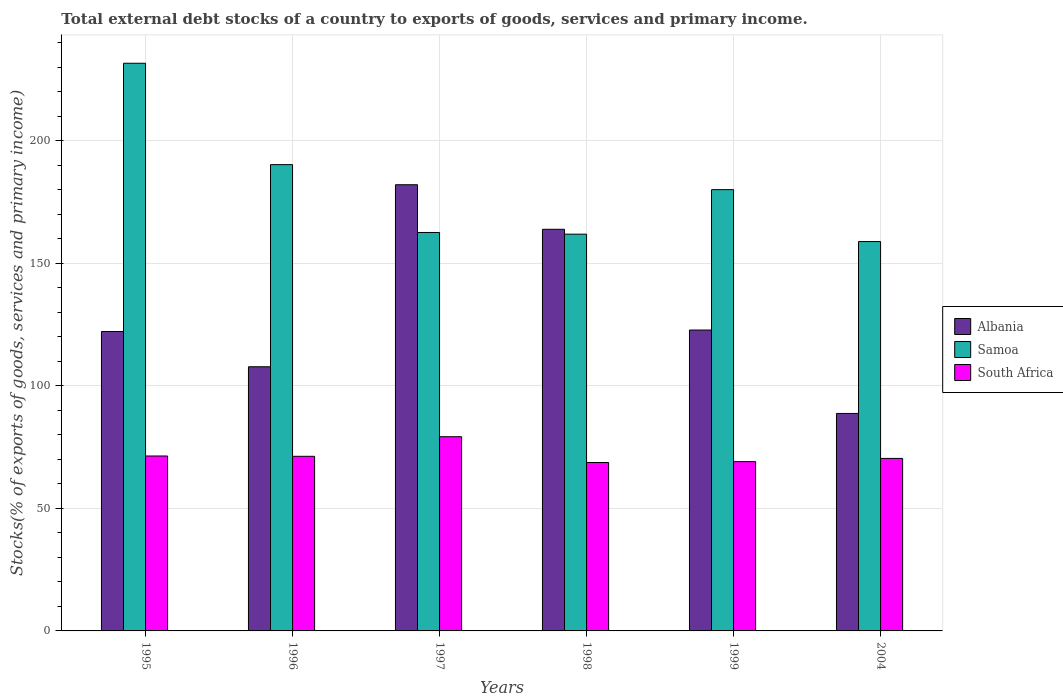How many different coloured bars are there?
Offer a terse response. 3. Are the number of bars per tick equal to the number of legend labels?
Offer a very short reply. Yes. Are the number of bars on each tick of the X-axis equal?
Your response must be concise. Yes. What is the label of the 1st group of bars from the left?
Provide a short and direct response. 1995. In how many cases, is the number of bars for a given year not equal to the number of legend labels?
Offer a terse response. 0. What is the total debt stocks in South Africa in 2004?
Keep it short and to the point. 70.36. Across all years, what is the maximum total debt stocks in Albania?
Keep it short and to the point. 182. Across all years, what is the minimum total debt stocks in Samoa?
Provide a succinct answer. 158.82. In which year was the total debt stocks in Albania maximum?
Offer a very short reply. 1997. What is the total total debt stocks in Samoa in the graph?
Provide a short and direct response. 1084.93. What is the difference between the total debt stocks in Albania in 1996 and that in 1998?
Offer a terse response. -56.08. What is the difference between the total debt stocks in South Africa in 1996 and the total debt stocks in Samoa in 1999?
Offer a terse response. -108.77. What is the average total debt stocks in Samoa per year?
Your answer should be very brief. 180.82. In the year 1999, what is the difference between the total debt stocks in Albania and total debt stocks in South Africa?
Make the answer very short. 53.68. In how many years, is the total debt stocks in South Africa greater than 140 %?
Your response must be concise. 0. What is the ratio of the total debt stocks in South Africa in 1998 to that in 2004?
Your answer should be compact. 0.98. Is the total debt stocks in Albania in 1998 less than that in 1999?
Offer a very short reply. No. Is the difference between the total debt stocks in Albania in 1996 and 1998 greater than the difference between the total debt stocks in South Africa in 1996 and 1998?
Keep it short and to the point. No. What is the difference between the highest and the second highest total debt stocks in South Africa?
Ensure brevity in your answer.  7.87. What is the difference between the highest and the lowest total debt stocks in Albania?
Provide a succinct answer. 93.29. What does the 3rd bar from the left in 1998 represents?
Your answer should be very brief. South Africa. What does the 1st bar from the right in 1998 represents?
Provide a short and direct response. South Africa. Is it the case that in every year, the sum of the total debt stocks in South Africa and total debt stocks in Albania is greater than the total debt stocks in Samoa?
Provide a short and direct response. No. How many bars are there?
Provide a succinct answer. 18. Are all the bars in the graph horizontal?
Keep it short and to the point. No. How many years are there in the graph?
Keep it short and to the point. 6. Does the graph contain grids?
Your answer should be very brief. Yes. Where does the legend appear in the graph?
Your answer should be very brief. Center right. How many legend labels are there?
Your answer should be compact. 3. What is the title of the graph?
Offer a very short reply. Total external debt stocks of a country to exports of goods, services and primary income. Does "Paraguay" appear as one of the legend labels in the graph?
Your answer should be compact. No. What is the label or title of the X-axis?
Give a very brief answer. Years. What is the label or title of the Y-axis?
Offer a very short reply. Stocks(% of exports of goods, services and primary income). What is the Stocks(% of exports of goods, services and primary income) in Albania in 1995?
Make the answer very short. 122.13. What is the Stocks(% of exports of goods, services and primary income) of Samoa in 1995?
Offer a very short reply. 231.55. What is the Stocks(% of exports of goods, services and primary income) of South Africa in 1995?
Give a very brief answer. 71.35. What is the Stocks(% of exports of goods, services and primary income) in Albania in 1996?
Provide a succinct answer. 107.75. What is the Stocks(% of exports of goods, services and primary income) in Samoa in 1996?
Your answer should be compact. 190.2. What is the Stocks(% of exports of goods, services and primary income) in South Africa in 1996?
Your answer should be very brief. 71.23. What is the Stocks(% of exports of goods, services and primary income) in Albania in 1997?
Give a very brief answer. 182. What is the Stocks(% of exports of goods, services and primary income) of Samoa in 1997?
Your response must be concise. 162.53. What is the Stocks(% of exports of goods, services and primary income) of South Africa in 1997?
Keep it short and to the point. 79.22. What is the Stocks(% of exports of goods, services and primary income) in Albania in 1998?
Offer a very short reply. 163.83. What is the Stocks(% of exports of goods, services and primary income) in Samoa in 1998?
Offer a terse response. 161.84. What is the Stocks(% of exports of goods, services and primary income) in South Africa in 1998?
Provide a succinct answer. 68.7. What is the Stocks(% of exports of goods, services and primary income) of Albania in 1999?
Give a very brief answer. 122.73. What is the Stocks(% of exports of goods, services and primary income) of Samoa in 1999?
Offer a very short reply. 180. What is the Stocks(% of exports of goods, services and primary income) in South Africa in 1999?
Make the answer very short. 69.05. What is the Stocks(% of exports of goods, services and primary income) in Albania in 2004?
Provide a short and direct response. 88.71. What is the Stocks(% of exports of goods, services and primary income) in Samoa in 2004?
Provide a succinct answer. 158.82. What is the Stocks(% of exports of goods, services and primary income) in South Africa in 2004?
Your answer should be very brief. 70.36. Across all years, what is the maximum Stocks(% of exports of goods, services and primary income) of Albania?
Provide a short and direct response. 182. Across all years, what is the maximum Stocks(% of exports of goods, services and primary income) in Samoa?
Ensure brevity in your answer.  231.55. Across all years, what is the maximum Stocks(% of exports of goods, services and primary income) of South Africa?
Your answer should be compact. 79.22. Across all years, what is the minimum Stocks(% of exports of goods, services and primary income) of Albania?
Offer a very short reply. 88.71. Across all years, what is the minimum Stocks(% of exports of goods, services and primary income) of Samoa?
Your response must be concise. 158.82. Across all years, what is the minimum Stocks(% of exports of goods, services and primary income) of South Africa?
Keep it short and to the point. 68.7. What is the total Stocks(% of exports of goods, services and primary income) in Albania in the graph?
Ensure brevity in your answer.  787.15. What is the total Stocks(% of exports of goods, services and primary income) in Samoa in the graph?
Your answer should be compact. 1084.93. What is the total Stocks(% of exports of goods, services and primary income) of South Africa in the graph?
Your response must be concise. 429.92. What is the difference between the Stocks(% of exports of goods, services and primary income) in Albania in 1995 and that in 1996?
Your answer should be compact. 14.38. What is the difference between the Stocks(% of exports of goods, services and primary income) of Samoa in 1995 and that in 1996?
Your answer should be very brief. 41.35. What is the difference between the Stocks(% of exports of goods, services and primary income) of South Africa in 1995 and that in 1996?
Offer a terse response. 0.13. What is the difference between the Stocks(% of exports of goods, services and primary income) of Albania in 1995 and that in 1997?
Make the answer very short. -59.87. What is the difference between the Stocks(% of exports of goods, services and primary income) of Samoa in 1995 and that in 1997?
Your response must be concise. 69.03. What is the difference between the Stocks(% of exports of goods, services and primary income) of South Africa in 1995 and that in 1997?
Provide a succinct answer. -7.87. What is the difference between the Stocks(% of exports of goods, services and primary income) in Albania in 1995 and that in 1998?
Your answer should be compact. -41.7. What is the difference between the Stocks(% of exports of goods, services and primary income) in Samoa in 1995 and that in 1998?
Your answer should be compact. 69.71. What is the difference between the Stocks(% of exports of goods, services and primary income) of South Africa in 1995 and that in 1998?
Provide a succinct answer. 2.66. What is the difference between the Stocks(% of exports of goods, services and primary income) in Albania in 1995 and that in 1999?
Your answer should be very brief. -0.6. What is the difference between the Stocks(% of exports of goods, services and primary income) of Samoa in 1995 and that in 1999?
Your answer should be compact. 51.55. What is the difference between the Stocks(% of exports of goods, services and primary income) in South Africa in 1995 and that in 1999?
Make the answer very short. 2.3. What is the difference between the Stocks(% of exports of goods, services and primary income) in Albania in 1995 and that in 2004?
Your response must be concise. 33.42. What is the difference between the Stocks(% of exports of goods, services and primary income) of Samoa in 1995 and that in 2004?
Keep it short and to the point. 72.73. What is the difference between the Stocks(% of exports of goods, services and primary income) in Albania in 1996 and that in 1997?
Offer a very short reply. -74.25. What is the difference between the Stocks(% of exports of goods, services and primary income) in Samoa in 1996 and that in 1997?
Provide a short and direct response. 27.67. What is the difference between the Stocks(% of exports of goods, services and primary income) in South Africa in 1996 and that in 1997?
Provide a short and direct response. -7.99. What is the difference between the Stocks(% of exports of goods, services and primary income) of Albania in 1996 and that in 1998?
Keep it short and to the point. -56.08. What is the difference between the Stocks(% of exports of goods, services and primary income) of Samoa in 1996 and that in 1998?
Offer a terse response. 28.36. What is the difference between the Stocks(% of exports of goods, services and primary income) in South Africa in 1996 and that in 1998?
Ensure brevity in your answer.  2.53. What is the difference between the Stocks(% of exports of goods, services and primary income) in Albania in 1996 and that in 1999?
Make the answer very short. -14.98. What is the difference between the Stocks(% of exports of goods, services and primary income) of Samoa in 1996 and that in 1999?
Give a very brief answer. 10.2. What is the difference between the Stocks(% of exports of goods, services and primary income) in South Africa in 1996 and that in 1999?
Provide a short and direct response. 2.18. What is the difference between the Stocks(% of exports of goods, services and primary income) of Albania in 1996 and that in 2004?
Your answer should be compact. 19.04. What is the difference between the Stocks(% of exports of goods, services and primary income) in Samoa in 1996 and that in 2004?
Give a very brief answer. 31.38. What is the difference between the Stocks(% of exports of goods, services and primary income) in South Africa in 1996 and that in 2004?
Keep it short and to the point. 0.86. What is the difference between the Stocks(% of exports of goods, services and primary income) of Albania in 1997 and that in 1998?
Give a very brief answer. 18.17. What is the difference between the Stocks(% of exports of goods, services and primary income) of Samoa in 1997 and that in 1998?
Provide a short and direct response. 0.68. What is the difference between the Stocks(% of exports of goods, services and primary income) in South Africa in 1997 and that in 1998?
Your answer should be very brief. 10.52. What is the difference between the Stocks(% of exports of goods, services and primary income) of Albania in 1997 and that in 1999?
Offer a terse response. 59.27. What is the difference between the Stocks(% of exports of goods, services and primary income) of Samoa in 1997 and that in 1999?
Give a very brief answer. -17.47. What is the difference between the Stocks(% of exports of goods, services and primary income) of South Africa in 1997 and that in 1999?
Provide a short and direct response. 10.17. What is the difference between the Stocks(% of exports of goods, services and primary income) of Albania in 1997 and that in 2004?
Ensure brevity in your answer.  93.29. What is the difference between the Stocks(% of exports of goods, services and primary income) of Samoa in 1997 and that in 2004?
Provide a succinct answer. 3.71. What is the difference between the Stocks(% of exports of goods, services and primary income) of South Africa in 1997 and that in 2004?
Give a very brief answer. 8.86. What is the difference between the Stocks(% of exports of goods, services and primary income) of Albania in 1998 and that in 1999?
Your response must be concise. 41.09. What is the difference between the Stocks(% of exports of goods, services and primary income) of Samoa in 1998 and that in 1999?
Provide a short and direct response. -18.16. What is the difference between the Stocks(% of exports of goods, services and primary income) of South Africa in 1998 and that in 1999?
Give a very brief answer. -0.35. What is the difference between the Stocks(% of exports of goods, services and primary income) in Albania in 1998 and that in 2004?
Give a very brief answer. 75.12. What is the difference between the Stocks(% of exports of goods, services and primary income) of Samoa in 1998 and that in 2004?
Your answer should be compact. 3.02. What is the difference between the Stocks(% of exports of goods, services and primary income) in South Africa in 1998 and that in 2004?
Your answer should be very brief. -1.67. What is the difference between the Stocks(% of exports of goods, services and primary income) of Albania in 1999 and that in 2004?
Offer a very short reply. 34.02. What is the difference between the Stocks(% of exports of goods, services and primary income) in Samoa in 1999 and that in 2004?
Offer a very short reply. 21.18. What is the difference between the Stocks(% of exports of goods, services and primary income) of South Africa in 1999 and that in 2004?
Your response must be concise. -1.31. What is the difference between the Stocks(% of exports of goods, services and primary income) of Albania in 1995 and the Stocks(% of exports of goods, services and primary income) of Samoa in 1996?
Provide a short and direct response. -68.07. What is the difference between the Stocks(% of exports of goods, services and primary income) in Albania in 1995 and the Stocks(% of exports of goods, services and primary income) in South Africa in 1996?
Your response must be concise. 50.9. What is the difference between the Stocks(% of exports of goods, services and primary income) in Samoa in 1995 and the Stocks(% of exports of goods, services and primary income) in South Africa in 1996?
Keep it short and to the point. 160.32. What is the difference between the Stocks(% of exports of goods, services and primary income) in Albania in 1995 and the Stocks(% of exports of goods, services and primary income) in Samoa in 1997?
Provide a short and direct response. -40.39. What is the difference between the Stocks(% of exports of goods, services and primary income) of Albania in 1995 and the Stocks(% of exports of goods, services and primary income) of South Africa in 1997?
Ensure brevity in your answer.  42.91. What is the difference between the Stocks(% of exports of goods, services and primary income) in Samoa in 1995 and the Stocks(% of exports of goods, services and primary income) in South Africa in 1997?
Provide a succinct answer. 152.33. What is the difference between the Stocks(% of exports of goods, services and primary income) in Albania in 1995 and the Stocks(% of exports of goods, services and primary income) in Samoa in 1998?
Provide a short and direct response. -39.71. What is the difference between the Stocks(% of exports of goods, services and primary income) of Albania in 1995 and the Stocks(% of exports of goods, services and primary income) of South Africa in 1998?
Offer a terse response. 53.43. What is the difference between the Stocks(% of exports of goods, services and primary income) in Samoa in 1995 and the Stocks(% of exports of goods, services and primary income) in South Africa in 1998?
Give a very brief answer. 162.85. What is the difference between the Stocks(% of exports of goods, services and primary income) in Albania in 1995 and the Stocks(% of exports of goods, services and primary income) in Samoa in 1999?
Make the answer very short. -57.87. What is the difference between the Stocks(% of exports of goods, services and primary income) of Albania in 1995 and the Stocks(% of exports of goods, services and primary income) of South Africa in 1999?
Give a very brief answer. 53.08. What is the difference between the Stocks(% of exports of goods, services and primary income) in Samoa in 1995 and the Stocks(% of exports of goods, services and primary income) in South Africa in 1999?
Your response must be concise. 162.5. What is the difference between the Stocks(% of exports of goods, services and primary income) of Albania in 1995 and the Stocks(% of exports of goods, services and primary income) of Samoa in 2004?
Your answer should be compact. -36.69. What is the difference between the Stocks(% of exports of goods, services and primary income) of Albania in 1995 and the Stocks(% of exports of goods, services and primary income) of South Africa in 2004?
Keep it short and to the point. 51.77. What is the difference between the Stocks(% of exports of goods, services and primary income) in Samoa in 1995 and the Stocks(% of exports of goods, services and primary income) in South Africa in 2004?
Make the answer very short. 161.19. What is the difference between the Stocks(% of exports of goods, services and primary income) in Albania in 1996 and the Stocks(% of exports of goods, services and primary income) in Samoa in 1997?
Provide a succinct answer. -54.77. What is the difference between the Stocks(% of exports of goods, services and primary income) of Albania in 1996 and the Stocks(% of exports of goods, services and primary income) of South Africa in 1997?
Ensure brevity in your answer.  28.53. What is the difference between the Stocks(% of exports of goods, services and primary income) of Samoa in 1996 and the Stocks(% of exports of goods, services and primary income) of South Africa in 1997?
Offer a very short reply. 110.98. What is the difference between the Stocks(% of exports of goods, services and primary income) of Albania in 1996 and the Stocks(% of exports of goods, services and primary income) of Samoa in 1998?
Your answer should be very brief. -54.09. What is the difference between the Stocks(% of exports of goods, services and primary income) in Albania in 1996 and the Stocks(% of exports of goods, services and primary income) in South Africa in 1998?
Give a very brief answer. 39.05. What is the difference between the Stocks(% of exports of goods, services and primary income) of Samoa in 1996 and the Stocks(% of exports of goods, services and primary income) of South Africa in 1998?
Make the answer very short. 121.5. What is the difference between the Stocks(% of exports of goods, services and primary income) of Albania in 1996 and the Stocks(% of exports of goods, services and primary income) of Samoa in 1999?
Provide a succinct answer. -72.25. What is the difference between the Stocks(% of exports of goods, services and primary income) in Albania in 1996 and the Stocks(% of exports of goods, services and primary income) in South Africa in 1999?
Ensure brevity in your answer.  38.7. What is the difference between the Stocks(% of exports of goods, services and primary income) in Samoa in 1996 and the Stocks(% of exports of goods, services and primary income) in South Africa in 1999?
Make the answer very short. 121.15. What is the difference between the Stocks(% of exports of goods, services and primary income) of Albania in 1996 and the Stocks(% of exports of goods, services and primary income) of Samoa in 2004?
Make the answer very short. -51.07. What is the difference between the Stocks(% of exports of goods, services and primary income) in Albania in 1996 and the Stocks(% of exports of goods, services and primary income) in South Africa in 2004?
Keep it short and to the point. 37.39. What is the difference between the Stocks(% of exports of goods, services and primary income) in Samoa in 1996 and the Stocks(% of exports of goods, services and primary income) in South Africa in 2004?
Your answer should be compact. 119.83. What is the difference between the Stocks(% of exports of goods, services and primary income) in Albania in 1997 and the Stocks(% of exports of goods, services and primary income) in Samoa in 1998?
Ensure brevity in your answer.  20.16. What is the difference between the Stocks(% of exports of goods, services and primary income) in Albania in 1997 and the Stocks(% of exports of goods, services and primary income) in South Africa in 1998?
Make the answer very short. 113.3. What is the difference between the Stocks(% of exports of goods, services and primary income) in Samoa in 1997 and the Stocks(% of exports of goods, services and primary income) in South Africa in 1998?
Keep it short and to the point. 93.83. What is the difference between the Stocks(% of exports of goods, services and primary income) in Albania in 1997 and the Stocks(% of exports of goods, services and primary income) in Samoa in 1999?
Give a very brief answer. 2. What is the difference between the Stocks(% of exports of goods, services and primary income) of Albania in 1997 and the Stocks(% of exports of goods, services and primary income) of South Africa in 1999?
Your answer should be compact. 112.95. What is the difference between the Stocks(% of exports of goods, services and primary income) of Samoa in 1997 and the Stocks(% of exports of goods, services and primary income) of South Africa in 1999?
Ensure brevity in your answer.  93.48. What is the difference between the Stocks(% of exports of goods, services and primary income) in Albania in 1997 and the Stocks(% of exports of goods, services and primary income) in Samoa in 2004?
Your answer should be very brief. 23.18. What is the difference between the Stocks(% of exports of goods, services and primary income) in Albania in 1997 and the Stocks(% of exports of goods, services and primary income) in South Africa in 2004?
Your answer should be compact. 111.63. What is the difference between the Stocks(% of exports of goods, services and primary income) of Samoa in 1997 and the Stocks(% of exports of goods, services and primary income) of South Africa in 2004?
Give a very brief answer. 92.16. What is the difference between the Stocks(% of exports of goods, services and primary income) in Albania in 1998 and the Stocks(% of exports of goods, services and primary income) in Samoa in 1999?
Ensure brevity in your answer.  -16.17. What is the difference between the Stocks(% of exports of goods, services and primary income) of Albania in 1998 and the Stocks(% of exports of goods, services and primary income) of South Africa in 1999?
Ensure brevity in your answer.  94.78. What is the difference between the Stocks(% of exports of goods, services and primary income) in Samoa in 1998 and the Stocks(% of exports of goods, services and primary income) in South Africa in 1999?
Your answer should be compact. 92.79. What is the difference between the Stocks(% of exports of goods, services and primary income) in Albania in 1998 and the Stocks(% of exports of goods, services and primary income) in Samoa in 2004?
Keep it short and to the point. 5.01. What is the difference between the Stocks(% of exports of goods, services and primary income) in Albania in 1998 and the Stocks(% of exports of goods, services and primary income) in South Africa in 2004?
Keep it short and to the point. 93.46. What is the difference between the Stocks(% of exports of goods, services and primary income) in Samoa in 1998 and the Stocks(% of exports of goods, services and primary income) in South Africa in 2004?
Provide a succinct answer. 91.48. What is the difference between the Stocks(% of exports of goods, services and primary income) in Albania in 1999 and the Stocks(% of exports of goods, services and primary income) in Samoa in 2004?
Ensure brevity in your answer.  -36.09. What is the difference between the Stocks(% of exports of goods, services and primary income) of Albania in 1999 and the Stocks(% of exports of goods, services and primary income) of South Africa in 2004?
Keep it short and to the point. 52.37. What is the difference between the Stocks(% of exports of goods, services and primary income) in Samoa in 1999 and the Stocks(% of exports of goods, services and primary income) in South Africa in 2004?
Your answer should be compact. 109.63. What is the average Stocks(% of exports of goods, services and primary income) of Albania per year?
Your answer should be very brief. 131.19. What is the average Stocks(% of exports of goods, services and primary income) in Samoa per year?
Your answer should be very brief. 180.82. What is the average Stocks(% of exports of goods, services and primary income) of South Africa per year?
Provide a short and direct response. 71.65. In the year 1995, what is the difference between the Stocks(% of exports of goods, services and primary income) of Albania and Stocks(% of exports of goods, services and primary income) of Samoa?
Ensure brevity in your answer.  -109.42. In the year 1995, what is the difference between the Stocks(% of exports of goods, services and primary income) of Albania and Stocks(% of exports of goods, services and primary income) of South Africa?
Make the answer very short. 50.78. In the year 1995, what is the difference between the Stocks(% of exports of goods, services and primary income) of Samoa and Stocks(% of exports of goods, services and primary income) of South Africa?
Your response must be concise. 160.2. In the year 1996, what is the difference between the Stocks(% of exports of goods, services and primary income) in Albania and Stocks(% of exports of goods, services and primary income) in Samoa?
Give a very brief answer. -82.45. In the year 1996, what is the difference between the Stocks(% of exports of goods, services and primary income) in Albania and Stocks(% of exports of goods, services and primary income) in South Africa?
Give a very brief answer. 36.52. In the year 1996, what is the difference between the Stocks(% of exports of goods, services and primary income) in Samoa and Stocks(% of exports of goods, services and primary income) in South Africa?
Keep it short and to the point. 118.97. In the year 1997, what is the difference between the Stocks(% of exports of goods, services and primary income) in Albania and Stocks(% of exports of goods, services and primary income) in Samoa?
Your answer should be compact. 19.47. In the year 1997, what is the difference between the Stocks(% of exports of goods, services and primary income) of Albania and Stocks(% of exports of goods, services and primary income) of South Africa?
Offer a terse response. 102.78. In the year 1997, what is the difference between the Stocks(% of exports of goods, services and primary income) of Samoa and Stocks(% of exports of goods, services and primary income) of South Africa?
Provide a short and direct response. 83.3. In the year 1998, what is the difference between the Stocks(% of exports of goods, services and primary income) in Albania and Stocks(% of exports of goods, services and primary income) in Samoa?
Offer a terse response. 1.99. In the year 1998, what is the difference between the Stocks(% of exports of goods, services and primary income) of Albania and Stocks(% of exports of goods, services and primary income) of South Africa?
Provide a succinct answer. 95.13. In the year 1998, what is the difference between the Stocks(% of exports of goods, services and primary income) in Samoa and Stocks(% of exports of goods, services and primary income) in South Africa?
Offer a terse response. 93.14. In the year 1999, what is the difference between the Stocks(% of exports of goods, services and primary income) of Albania and Stocks(% of exports of goods, services and primary income) of Samoa?
Your answer should be very brief. -57.27. In the year 1999, what is the difference between the Stocks(% of exports of goods, services and primary income) of Albania and Stocks(% of exports of goods, services and primary income) of South Africa?
Ensure brevity in your answer.  53.68. In the year 1999, what is the difference between the Stocks(% of exports of goods, services and primary income) of Samoa and Stocks(% of exports of goods, services and primary income) of South Africa?
Your answer should be compact. 110.95. In the year 2004, what is the difference between the Stocks(% of exports of goods, services and primary income) in Albania and Stocks(% of exports of goods, services and primary income) in Samoa?
Provide a succinct answer. -70.11. In the year 2004, what is the difference between the Stocks(% of exports of goods, services and primary income) of Albania and Stocks(% of exports of goods, services and primary income) of South Africa?
Give a very brief answer. 18.35. In the year 2004, what is the difference between the Stocks(% of exports of goods, services and primary income) of Samoa and Stocks(% of exports of goods, services and primary income) of South Africa?
Your response must be concise. 88.46. What is the ratio of the Stocks(% of exports of goods, services and primary income) of Albania in 1995 to that in 1996?
Your answer should be compact. 1.13. What is the ratio of the Stocks(% of exports of goods, services and primary income) of Samoa in 1995 to that in 1996?
Your response must be concise. 1.22. What is the ratio of the Stocks(% of exports of goods, services and primary income) of Albania in 1995 to that in 1997?
Make the answer very short. 0.67. What is the ratio of the Stocks(% of exports of goods, services and primary income) of Samoa in 1995 to that in 1997?
Keep it short and to the point. 1.42. What is the ratio of the Stocks(% of exports of goods, services and primary income) in South Africa in 1995 to that in 1997?
Provide a short and direct response. 0.9. What is the ratio of the Stocks(% of exports of goods, services and primary income) of Albania in 1995 to that in 1998?
Ensure brevity in your answer.  0.75. What is the ratio of the Stocks(% of exports of goods, services and primary income) in Samoa in 1995 to that in 1998?
Keep it short and to the point. 1.43. What is the ratio of the Stocks(% of exports of goods, services and primary income) of South Africa in 1995 to that in 1998?
Offer a terse response. 1.04. What is the ratio of the Stocks(% of exports of goods, services and primary income) of Samoa in 1995 to that in 1999?
Make the answer very short. 1.29. What is the ratio of the Stocks(% of exports of goods, services and primary income) of South Africa in 1995 to that in 1999?
Offer a very short reply. 1.03. What is the ratio of the Stocks(% of exports of goods, services and primary income) of Albania in 1995 to that in 2004?
Offer a terse response. 1.38. What is the ratio of the Stocks(% of exports of goods, services and primary income) in Samoa in 1995 to that in 2004?
Keep it short and to the point. 1.46. What is the ratio of the Stocks(% of exports of goods, services and primary income) of South Africa in 1995 to that in 2004?
Ensure brevity in your answer.  1.01. What is the ratio of the Stocks(% of exports of goods, services and primary income) of Albania in 1996 to that in 1997?
Make the answer very short. 0.59. What is the ratio of the Stocks(% of exports of goods, services and primary income) in Samoa in 1996 to that in 1997?
Offer a very short reply. 1.17. What is the ratio of the Stocks(% of exports of goods, services and primary income) of South Africa in 1996 to that in 1997?
Keep it short and to the point. 0.9. What is the ratio of the Stocks(% of exports of goods, services and primary income) of Albania in 1996 to that in 1998?
Your answer should be very brief. 0.66. What is the ratio of the Stocks(% of exports of goods, services and primary income) of Samoa in 1996 to that in 1998?
Your answer should be compact. 1.18. What is the ratio of the Stocks(% of exports of goods, services and primary income) of South Africa in 1996 to that in 1998?
Keep it short and to the point. 1.04. What is the ratio of the Stocks(% of exports of goods, services and primary income) of Albania in 1996 to that in 1999?
Your answer should be compact. 0.88. What is the ratio of the Stocks(% of exports of goods, services and primary income) in Samoa in 1996 to that in 1999?
Provide a succinct answer. 1.06. What is the ratio of the Stocks(% of exports of goods, services and primary income) of South Africa in 1996 to that in 1999?
Offer a terse response. 1.03. What is the ratio of the Stocks(% of exports of goods, services and primary income) in Albania in 1996 to that in 2004?
Ensure brevity in your answer.  1.21. What is the ratio of the Stocks(% of exports of goods, services and primary income) in Samoa in 1996 to that in 2004?
Your answer should be compact. 1.2. What is the ratio of the Stocks(% of exports of goods, services and primary income) of South Africa in 1996 to that in 2004?
Your response must be concise. 1.01. What is the ratio of the Stocks(% of exports of goods, services and primary income) of Albania in 1997 to that in 1998?
Keep it short and to the point. 1.11. What is the ratio of the Stocks(% of exports of goods, services and primary income) of South Africa in 1997 to that in 1998?
Offer a terse response. 1.15. What is the ratio of the Stocks(% of exports of goods, services and primary income) of Albania in 1997 to that in 1999?
Make the answer very short. 1.48. What is the ratio of the Stocks(% of exports of goods, services and primary income) in Samoa in 1997 to that in 1999?
Keep it short and to the point. 0.9. What is the ratio of the Stocks(% of exports of goods, services and primary income) of South Africa in 1997 to that in 1999?
Make the answer very short. 1.15. What is the ratio of the Stocks(% of exports of goods, services and primary income) of Albania in 1997 to that in 2004?
Give a very brief answer. 2.05. What is the ratio of the Stocks(% of exports of goods, services and primary income) in Samoa in 1997 to that in 2004?
Provide a succinct answer. 1.02. What is the ratio of the Stocks(% of exports of goods, services and primary income) of South Africa in 1997 to that in 2004?
Provide a succinct answer. 1.13. What is the ratio of the Stocks(% of exports of goods, services and primary income) of Albania in 1998 to that in 1999?
Provide a succinct answer. 1.33. What is the ratio of the Stocks(% of exports of goods, services and primary income) of Samoa in 1998 to that in 1999?
Your response must be concise. 0.9. What is the ratio of the Stocks(% of exports of goods, services and primary income) in Albania in 1998 to that in 2004?
Your answer should be very brief. 1.85. What is the ratio of the Stocks(% of exports of goods, services and primary income) of South Africa in 1998 to that in 2004?
Offer a terse response. 0.98. What is the ratio of the Stocks(% of exports of goods, services and primary income) of Albania in 1999 to that in 2004?
Give a very brief answer. 1.38. What is the ratio of the Stocks(% of exports of goods, services and primary income) in Samoa in 1999 to that in 2004?
Make the answer very short. 1.13. What is the ratio of the Stocks(% of exports of goods, services and primary income) in South Africa in 1999 to that in 2004?
Your response must be concise. 0.98. What is the difference between the highest and the second highest Stocks(% of exports of goods, services and primary income) of Albania?
Offer a very short reply. 18.17. What is the difference between the highest and the second highest Stocks(% of exports of goods, services and primary income) of Samoa?
Your response must be concise. 41.35. What is the difference between the highest and the second highest Stocks(% of exports of goods, services and primary income) of South Africa?
Make the answer very short. 7.87. What is the difference between the highest and the lowest Stocks(% of exports of goods, services and primary income) of Albania?
Your response must be concise. 93.29. What is the difference between the highest and the lowest Stocks(% of exports of goods, services and primary income) in Samoa?
Your response must be concise. 72.73. What is the difference between the highest and the lowest Stocks(% of exports of goods, services and primary income) of South Africa?
Ensure brevity in your answer.  10.52. 